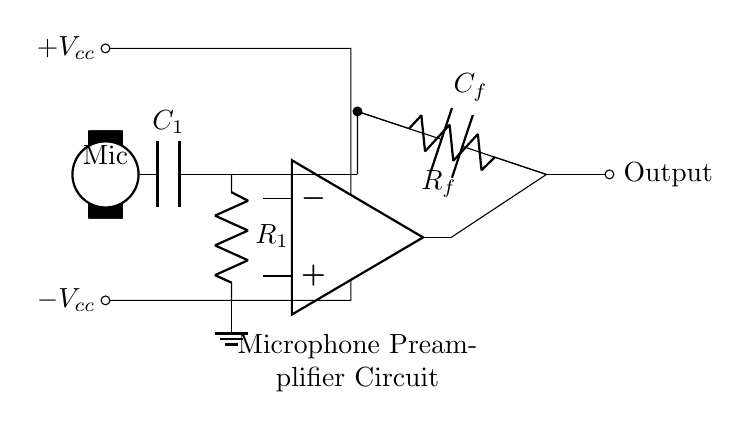What type of components are present in this circuit? The circuit shows an operational amplifier, resistors, capacitors, and a microphone. These components are essential for the function of a preamplifier.
Answer: operational amplifier, resistors, capacitors, microphone What is the function of C1 in this circuit? C1 acts as an input capacitor, blocking any DC component from the microphone signal while allowing the AC voice signal to pass to the resistor R1.
Answer: input capacitor How is the output taken from the circuit? The output is taken at the right side of Rf, where it is marked as 'Output.' This is typically where the amplified signal is accessible for further processing.
Answer: from Rf What does Rf indicate in this circuit? Rf is a feedback resistor that is used to set the gain of the operational amplifier, affecting the amplification level of the signal being processed.
Answer: feedback resistor What are the power supply voltages provided to the op-amp? The op-amp in this circuit is powered by positive and negative voltage supplies marked as +Vcc and -Vcc, which provide the necessary power for operation.
Answer: +Vcc and -Vcc What is the overall purpose of this circuit? This circuit is designed to amplify low-level audio signals from a microphone to a higher level suitable for further audio processing or recording.
Answer: microphone preamplifier How does the feedback network influence the circuit's performance? The feedback network consisting of Rf and Cf stabilizes the operation of the op-amp and determines the frequency response and gain of the circuit, allowing it to function effectively for audio signals.
Answer: stabilizes gain 